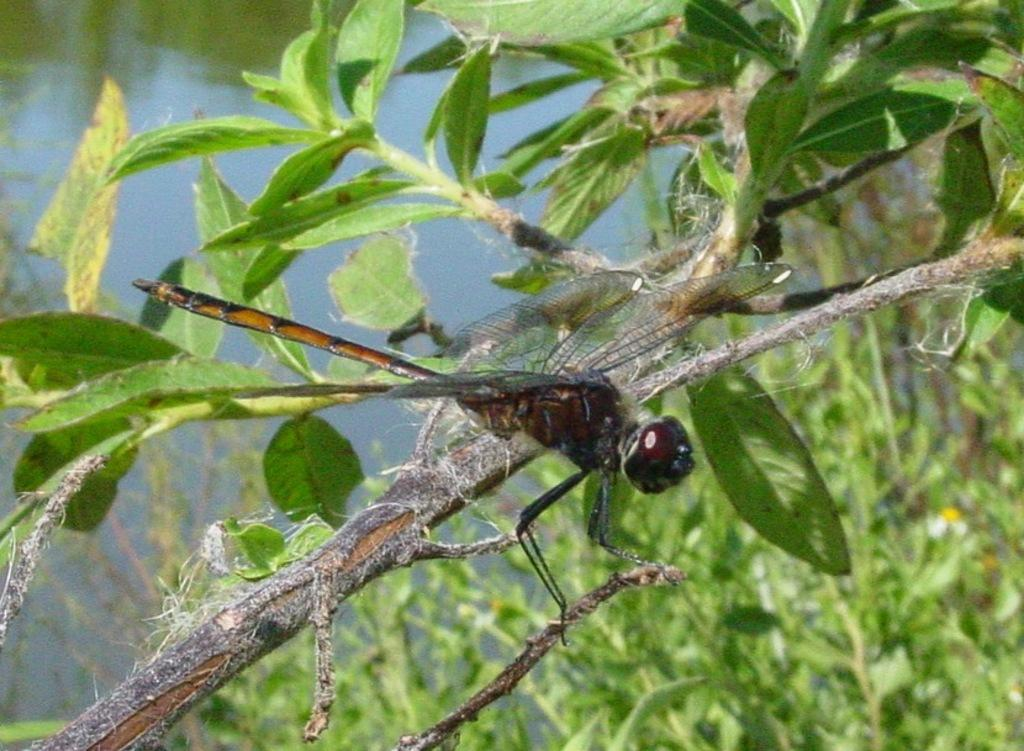What insect can be seen in the picture? There is a dragonfly in the picture. What other living organisms are present in the image? There are plants visible in the picture. What can be seen in the background of the picture? Water is visible in the background of the picture. Can you tell me how many fairies are sitting on the grape in the image? There are no fairies or grapes present in the image; it features a dragonfly and plants. 